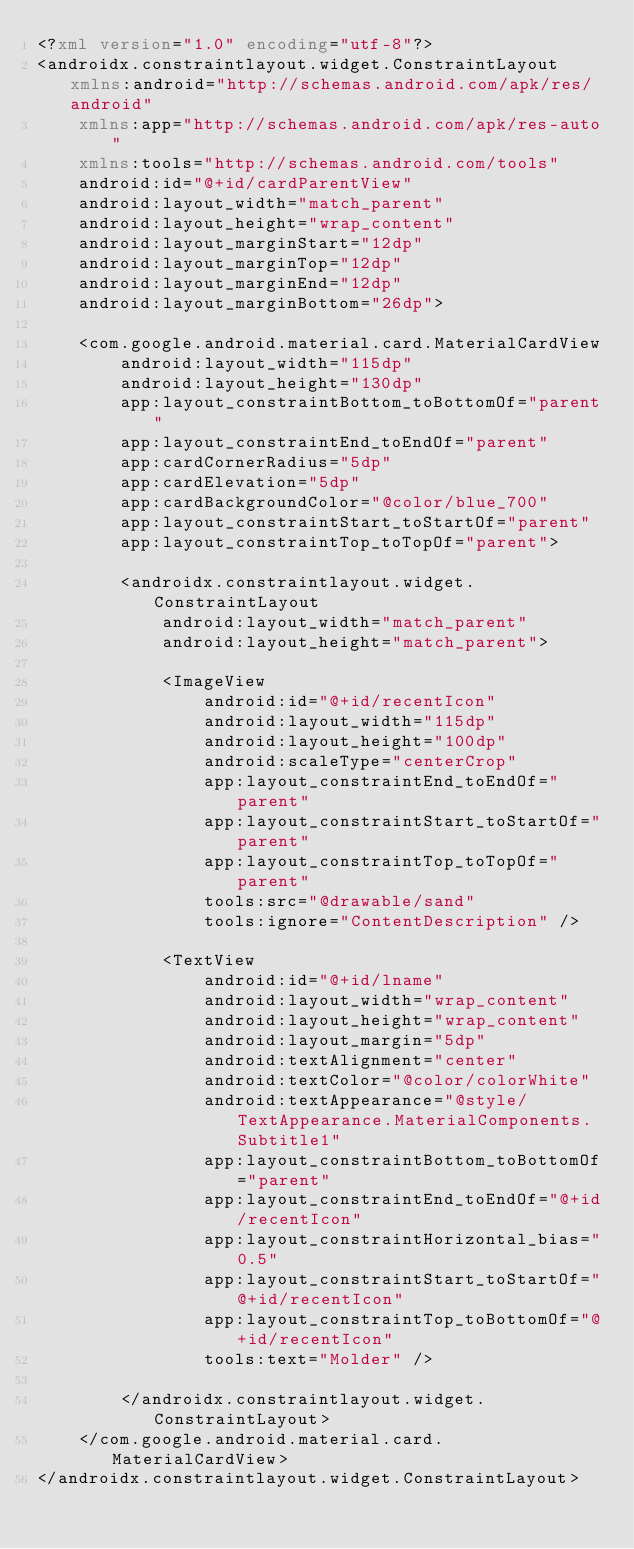<code> <loc_0><loc_0><loc_500><loc_500><_XML_><?xml version="1.0" encoding="utf-8"?>
<androidx.constraintlayout.widget.ConstraintLayout xmlns:android="http://schemas.android.com/apk/res/android"
    xmlns:app="http://schemas.android.com/apk/res-auto"
    xmlns:tools="http://schemas.android.com/tools"
    android:id="@+id/cardParentView"
    android:layout_width="match_parent"
    android:layout_height="wrap_content"
    android:layout_marginStart="12dp"
    android:layout_marginTop="12dp"
    android:layout_marginEnd="12dp"
    android:layout_marginBottom="26dp">

    <com.google.android.material.card.MaterialCardView
        android:layout_width="115dp"
        android:layout_height="130dp"
        app:layout_constraintBottom_toBottomOf="parent"
        app:layout_constraintEnd_toEndOf="parent"
        app:cardCornerRadius="5dp"
        app:cardElevation="5dp"
        app:cardBackgroundColor="@color/blue_700"
        app:layout_constraintStart_toStartOf="parent"
        app:layout_constraintTop_toTopOf="parent">

        <androidx.constraintlayout.widget.ConstraintLayout
            android:layout_width="match_parent"
            android:layout_height="match_parent">

            <ImageView
                android:id="@+id/recentIcon"
                android:layout_width="115dp"
                android:layout_height="100dp"
                android:scaleType="centerCrop"
                app:layout_constraintEnd_toEndOf="parent"
                app:layout_constraintStart_toStartOf="parent"
                app:layout_constraintTop_toTopOf="parent"
                tools:src="@drawable/sand"
                tools:ignore="ContentDescription" />

            <TextView
                android:id="@+id/lname"
                android:layout_width="wrap_content"
                android:layout_height="wrap_content"
                android:layout_margin="5dp"
                android:textAlignment="center"
                android:textColor="@color/colorWhite"
                android:textAppearance="@style/TextAppearance.MaterialComponents.Subtitle1"
                app:layout_constraintBottom_toBottomOf="parent"
                app:layout_constraintEnd_toEndOf="@+id/recentIcon"
                app:layout_constraintHorizontal_bias="0.5"
                app:layout_constraintStart_toStartOf="@+id/recentIcon"
                app:layout_constraintTop_toBottomOf="@+id/recentIcon"
                tools:text="Molder" />

        </androidx.constraintlayout.widget.ConstraintLayout>
    </com.google.android.material.card.MaterialCardView>
</androidx.constraintlayout.widget.ConstraintLayout></code> 